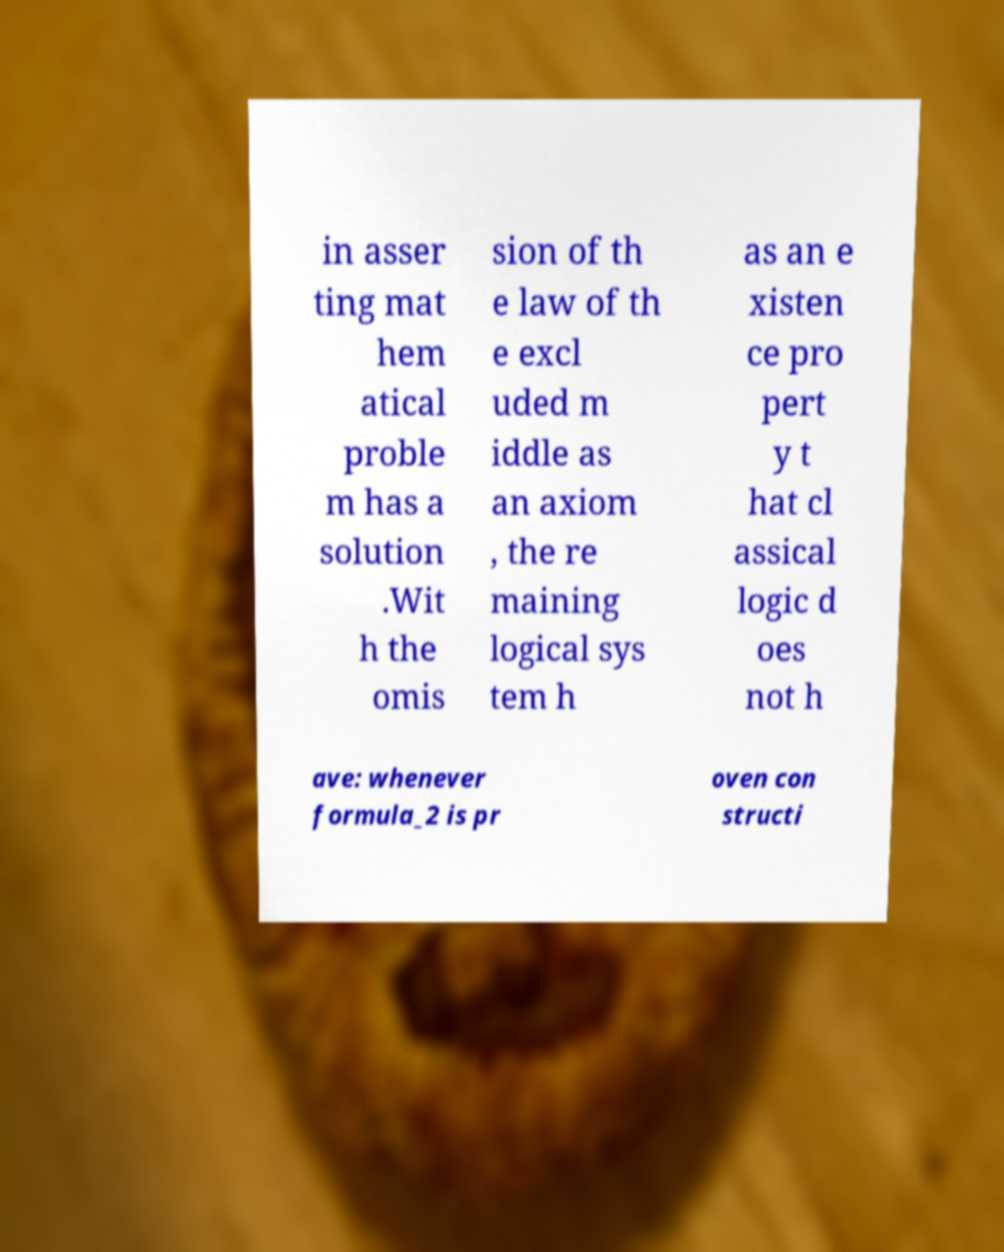What messages or text are displayed in this image? I need them in a readable, typed format. in asser ting mat hem atical proble m has a solution .Wit h the omis sion of th e law of th e excl uded m iddle as an axiom , the re maining logical sys tem h as an e xisten ce pro pert y t hat cl assical logic d oes not h ave: whenever formula_2 is pr oven con structi 